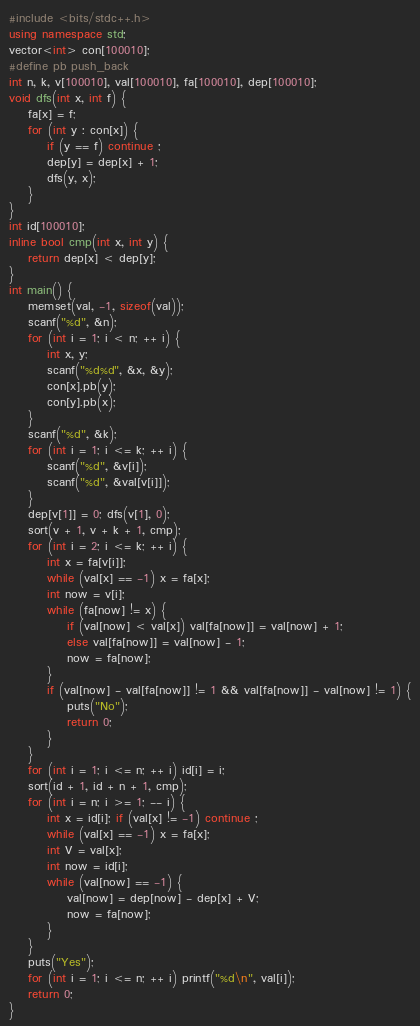Convert code to text. <code><loc_0><loc_0><loc_500><loc_500><_C++_>#include <bits/stdc++.h>
using namespace std;
vector<int> con[100010];
#define pb push_back
int n, k, v[100010], val[100010], fa[100010], dep[100010];
void dfs(int x, int f) {
	fa[x] = f;
	for (int y : con[x]) {
		if (y == f) continue ;
		dep[y] = dep[x] + 1;
		dfs(y, x);
	}
}
int id[100010];
inline bool cmp(int x, int y) {
	return dep[x] < dep[y];
}
int main() {
	memset(val, -1, sizeof(val));
	scanf("%d", &n);
	for (int i = 1; i < n; ++ i) {
		int x, y;
		scanf("%d%d", &x, &y);
		con[x].pb(y);
		con[y].pb(x);
	}
	scanf("%d", &k);
	for (int i = 1; i <= k; ++ i) {
		scanf("%d", &v[i]);
		scanf("%d", &val[v[i]]);
	}
	dep[v[1]] = 0; dfs(v[1], 0);
	sort(v + 1, v + k + 1, cmp);
	for (int i = 2; i <= k; ++ i) {
		int x = fa[v[i]];
		while (val[x] == -1) x = fa[x];
		int now = v[i];
		while (fa[now] != x) {
			if (val[now] < val[x]) val[fa[now]] = val[now] + 1;
			else val[fa[now]] = val[now] - 1;
			now = fa[now];
		}
		if (val[now] - val[fa[now]] != 1 && val[fa[now]] - val[now] != 1) {
			puts("No");
			return 0;
		}
	}
	for (int i = 1; i <= n; ++ i) id[i] = i;
	sort(id + 1, id + n + 1, cmp);
	for (int i = n; i >= 1; -- i) {
		int x = id[i]; if (val[x] != -1) continue ;
		while (val[x] == -1) x = fa[x];
		int V = val[x];
		int now = id[i];
		while (val[now] == -1) {
			val[now] = dep[now] - dep[x] + V;
			now = fa[now];
		}
	}
	puts("Yes");
	for (int i = 1; i <= n; ++ i) printf("%d\n", val[i]);
	return 0;
}</code> 